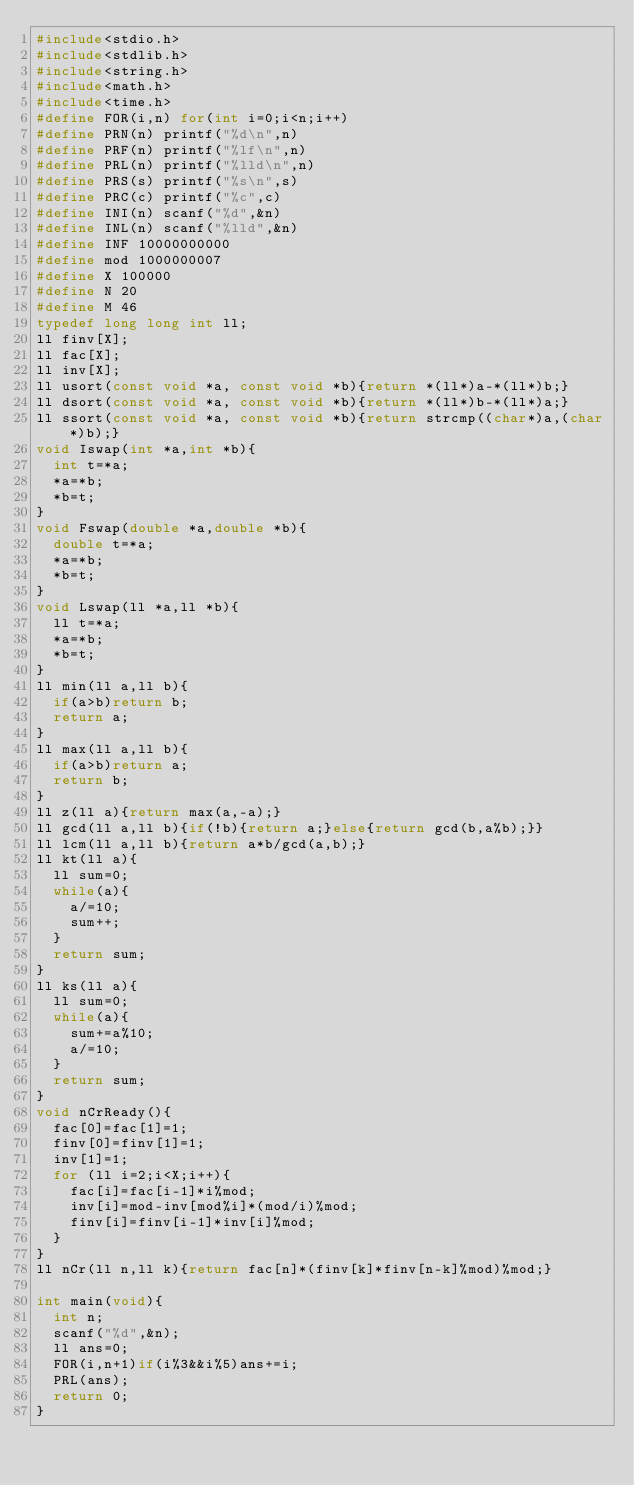<code> <loc_0><loc_0><loc_500><loc_500><_C_>#include<stdio.h>
#include<stdlib.h>
#include<string.h>
#include<math.h>
#include<time.h>
#define FOR(i,n) for(int i=0;i<n;i++)
#define PRN(n) printf("%d\n",n)
#define PRF(n) printf("%lf\n",n)
#define PRL(n) printf("%lld\n",n)
#define PRS(s) printf("%s\n",s)
#define PRC(c) printf("%c",c)
#define INI(n) scanf("%d",&n)
#define INL(n) scanf("%lld",&n)
#define INF 10000000000
#define mod 1000000007
#define X 100000
#define N 20
#define M 46
typedef long long int ll;
ll finv[X];
ll fac[X];
ll inv[X];
ll usort(const void *a, const void *b){return *(ll*)a-*(ll*)b;}
ll dsort(const void *a, const void *b){return *(ll*)b-*(ll*)a;}
ll ssort(const void *a, const void *b){return strcmp((char*)a,(char*)b);}
void Iswap(int *a,int *b){
  int t=*a;
  *a=*b;
  *b=t;
}
void Fswap(double *a,double *b){
  double t=*a;
  *a=*b;
  *b=t;
}
void Lswap(ll *a,ll *b){
  ll t=*a;
  *a=*b;
  *b=t;
}
ll min(ll a,ll b){
  if(a>b)return b;
  return a;
}
ll max(ll a,ll b){
  if(a>b)return a;
  return b;
}
ll z(ll a){return max(a,-a);}
ll gcd(ll a,ll b){if(!b){return a;}else{return gcd(b,a%b);}}
ll lcm(ll a,ll b){return a*b/gcd(a,b);}
ll kt(ll a){
  ll sum=0;
  while(a){
    a/=10;
    sum++;
  }
  return sum;
}
ll ks(ll a){
  ll sum=0;
  while(a){
    sum+=a%10;
    a/=10;
  }
  return sum;
}
void nCrReady(){
  fac[0]=fac[1]=1;
  finv[0]=finv[1]=1;
  inv[1]=1;
  for (ll i=2;i<X;i++){
    fac[i]=fac[i-1]*i%mod;
    inv[i]=mod-inv[mod%i]*(mod/i)%mod;
    finv[i]=finv[i-1]*inv[i]%mod;
  }
}
ll nCr(ll n,ll k){return fac[n]*(finv[k]*finv[n-k]%mod)%mod;}

int main(void){
  int n;
  scanf("%d",&n);
  ll ans=0;
  FOR(i,n+1)if(i%3&&i%5)ans+=i;
  PRL(ans);
  return 0;
}</code> 